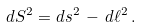Convert formula to latex. <formula><loc_0><loc_0><loc_500><loc_500>d S ^ { 2 } = d s ^ { 2 } \, - \, d \ell ^ { 2 } \, .</formula> 